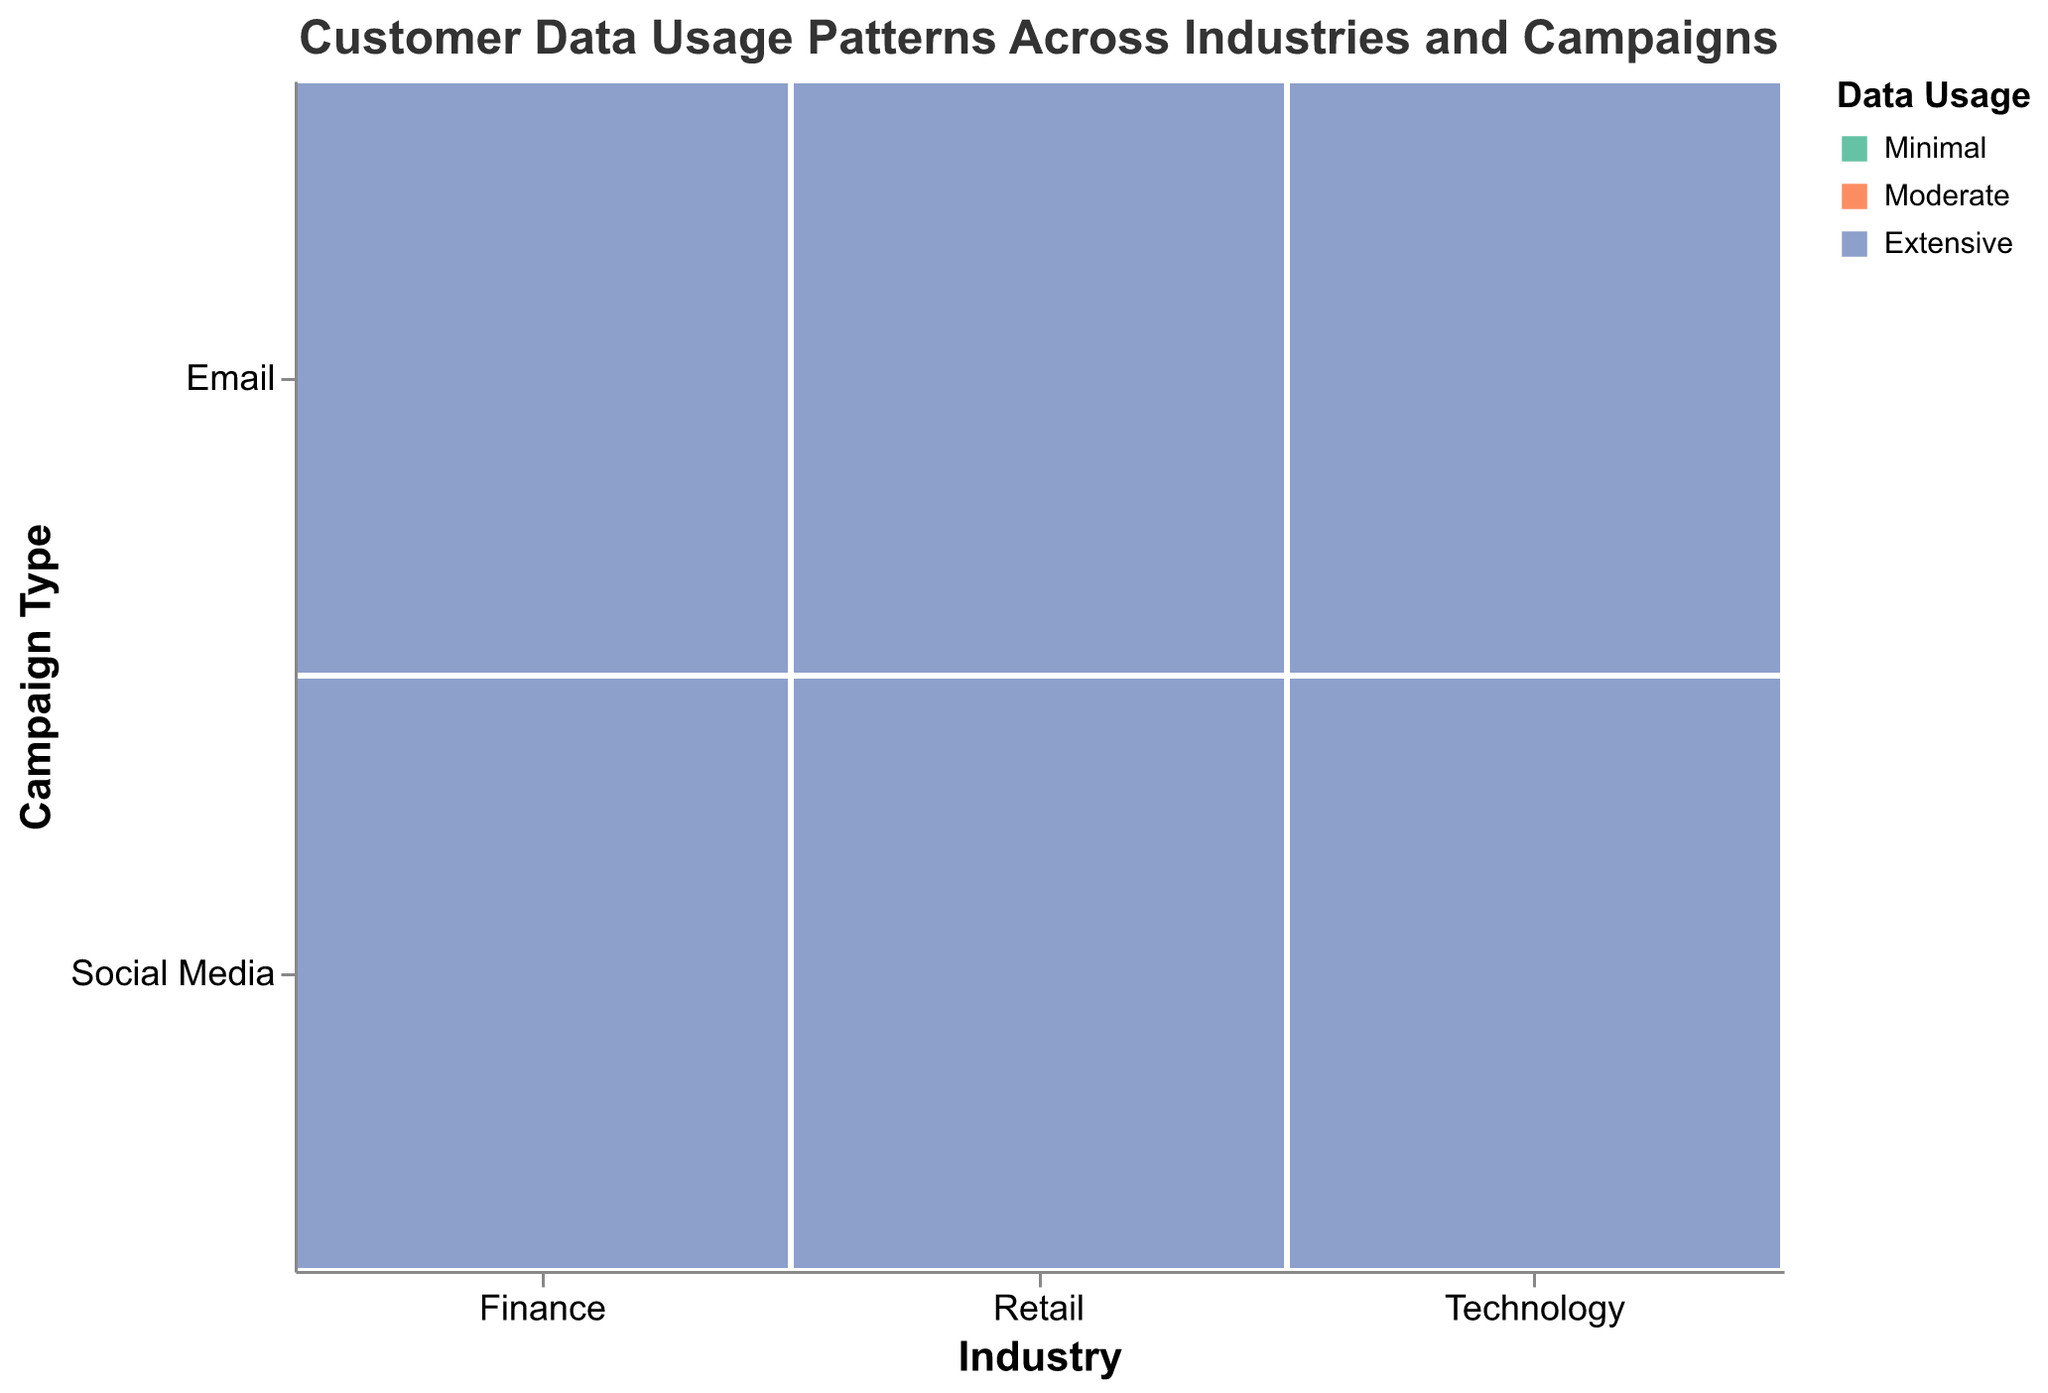Which industry has the highest customer count for social media campaigns? To find this, look at the size of the rectangles representing social media campaigns across different industries. The Technology industry has the largest rectangles for social media data usage compared to Retail and Finance.
Answer: Technology In the Retail industry, do email campaigns have more customers with extensive data usage or moderate data usage? Compare the sizes of the rectangles under Retail -> Email for "Extensive" and "Moderate" data usage. The rectangle for moderate data usage is larger than the one for extensive data usage.
Answer: Moderate What is the total customer count for Minimal data usage in the Finance industry? Add up customer counts for "Minimal" data usage under Finance for both campaign types: 950 (Email) + 1100 (Social Media) = 2050.
Answer: 2050 Which industry has the lowest customer count for email campaigns with minimal data usage? Compare the size of the rectangles for "Minimal" data usage under Email campaigns for each industry. Finance has the smallest size rectangle.
Answer: Finance Do Technology industry social media campaigns have a higher proportion of customers with moderate data usage compared to extensive data usage? Compare the sizes of the rectangles under Technology -> Social Media for "Moderate" and "Extensive" data usage. The "Moderate" rectangle is larger, indicating more customers.
Answer: Yes What is the customer count difference between moderate and extensive data usage for Social Media campaigns in the Retail industry? Subtract the customer count of extensive data usage (3900) from that of moderate data usage (5600) in Retail -> Social Media: 5600 - 3900 = 1700.
Answer: 1700 Which campaign type in the Technology industry has the most extensive data usage? Compare the sizes of the rectangles for "Extensive" data usage under Technology -> Email and Technology -> Social Media. Social Media has a larger rectangle.
Answer: Social Media What is the most common data usage pattern in the Finance industry for email campaigns? Identify the largest rectangle under Finance -> Email. The largest is for "Moderate" data usage.
Answer: Moderate How does the customer count for minimal data usage in retail social media campaigns compare to finance social media campaigns? Compare the sizes of the rectangles for "Minimal" data usage under Social Media for Retail (2300) and Finance (1100). Retail has a larger rectangle.
Answer: Larger in Retail What is the combined customer count of moderate and extensive data usage in Technology industry email campaigns? Add the customer counts for moderate (4200) and extensive (3100) data usage in Technology -> Email: 4200 + 3100 = 7300.
Answer: 7300 